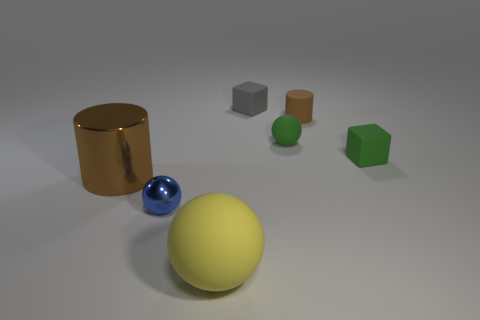There is another cylinder that is the same color as the large metal cylinder; what size is it?
Make the answer very short. Small. What number of rubber objects are the same color as the big cylinder?
Offer a terse response. 1. Do the blue thing and the yellow matte thing that is in front of the small shiny ball have the same shape?
Ensure brevity in your answer.  Yes. What is the material of the large brown object?
Provide a short and direct response. Metal. What is the color of the sphere on the right side of the matte sphere to the left of the tiny sphere that is behind the large brown cylinder?
Ensure brevity in your answer.  Green. What material is the other large object that is the same shape as the brown matte object?
Provide a short and direct response. Metal. How many other rubber balls have the same size as the green sphere?
Ensure brevity in your answer.  0. What number of big metallic cylinders are there?
Provide a succinct answer. 1. Does the tiny gray cube have the same material as the small sphere in front of the brown metal cylinder?
Provide a short and direct response. No. How many blue objects are blocks or balls?
Offer a terse response. 1. 